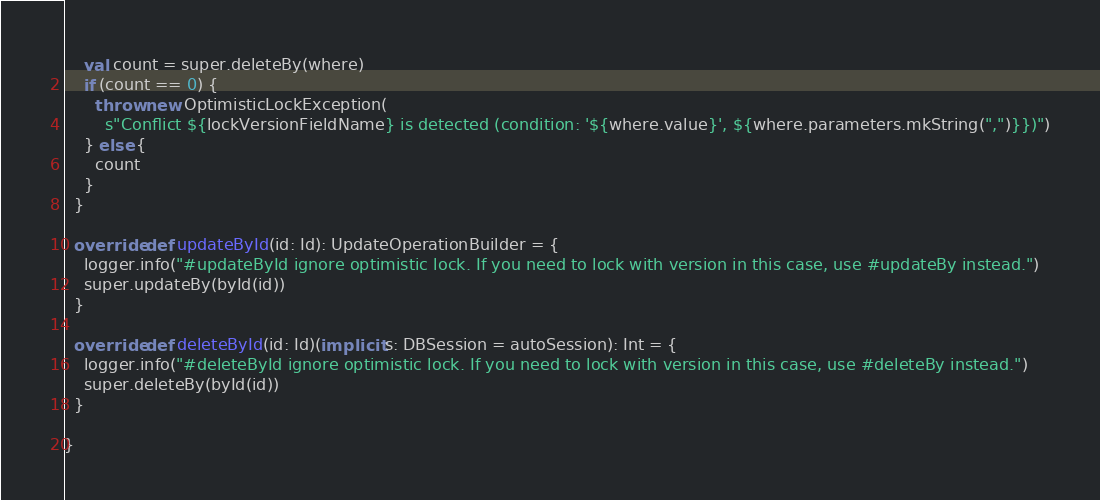<code> <loc_0><loc_0><loc_500><loc_500><_Scala_>    val count = super.deleteBy(where)
    if (count == 0) {
      throw new OptimisticLockException(
        s"Conflict ${lockVersionFieldName} is detected (condition: '${where.value}', ${where.parameters.mkString(",")}})")
    } else {
      count
    }
  }

  override def updateById(id: Id): UpdateOperationBuilder = {
    logger.info("#updateById ignore optimistic lock. If you need to lock with version in this case, use #updateBy instead.")
    super.updateBy(byId(id))
  }

  override def deleteById(id: Id)(implicit s: DBSession = autoSession): Int = {
    logger.info("#deleteById ignore optimistic lock. If you need to lock with version in this case, use #deleteBy instead.")
    super.deleteBy(byId(id))
  }

}
</code> 